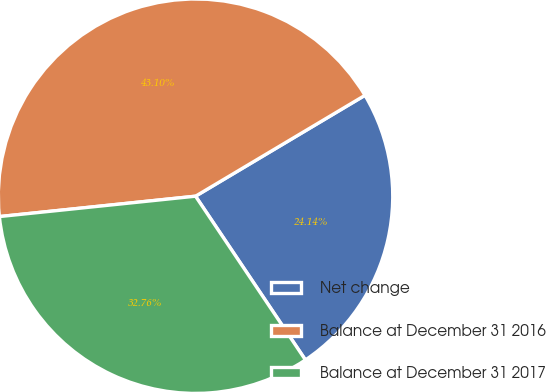<chart> <loc_0><loc_0><loc_500><loc_500><pie_chart><fcel>Net change<fcel>Balance at December 31 2016<fcel>Balance at December 31 2017<nl><fcel>24.14%<fcel>43.1%<fcel>32.76%<nl></chart> 